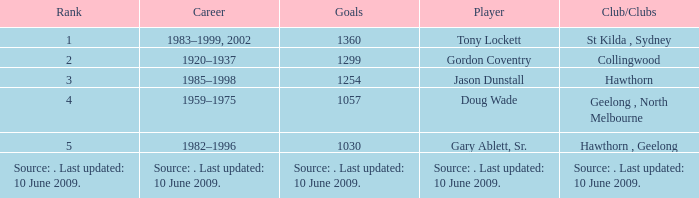Give me the full table as a dictionary. {'header': ['Rank', 'Career', 'Goals', 'Player', 'Club/Clubs'], 'rows': [['1', '1983–1999, 2002', '1360', 'Tony Lockett', 'St Kilda , Sydney'], ['2', '1920–1937', '1299', 'Gordon Coventry', 'Collingwood'], ['3', '1985–1998', '1254', 'Jason Dunstall', 'Hawthorn'], ['4', '1959–1975', '1057', 'Doug Wade', 'Geelong , North Melbourne'], ['5', '1982–1996', '1030', 'Gary Ablett, Sr.', 'Hawthorn , Geelong'], ['Source: . Last updated: 10 June 2009.', 'Source: . Last updated: 10 June 2009.', 'Source: . Last updated: 10 June 2009.', 'Source: . Last updated: 10 June 2009.', 'Source: . Last updated: 10 June 2009.']]} What is the rank of player Jason Dunstall? 3.0. 